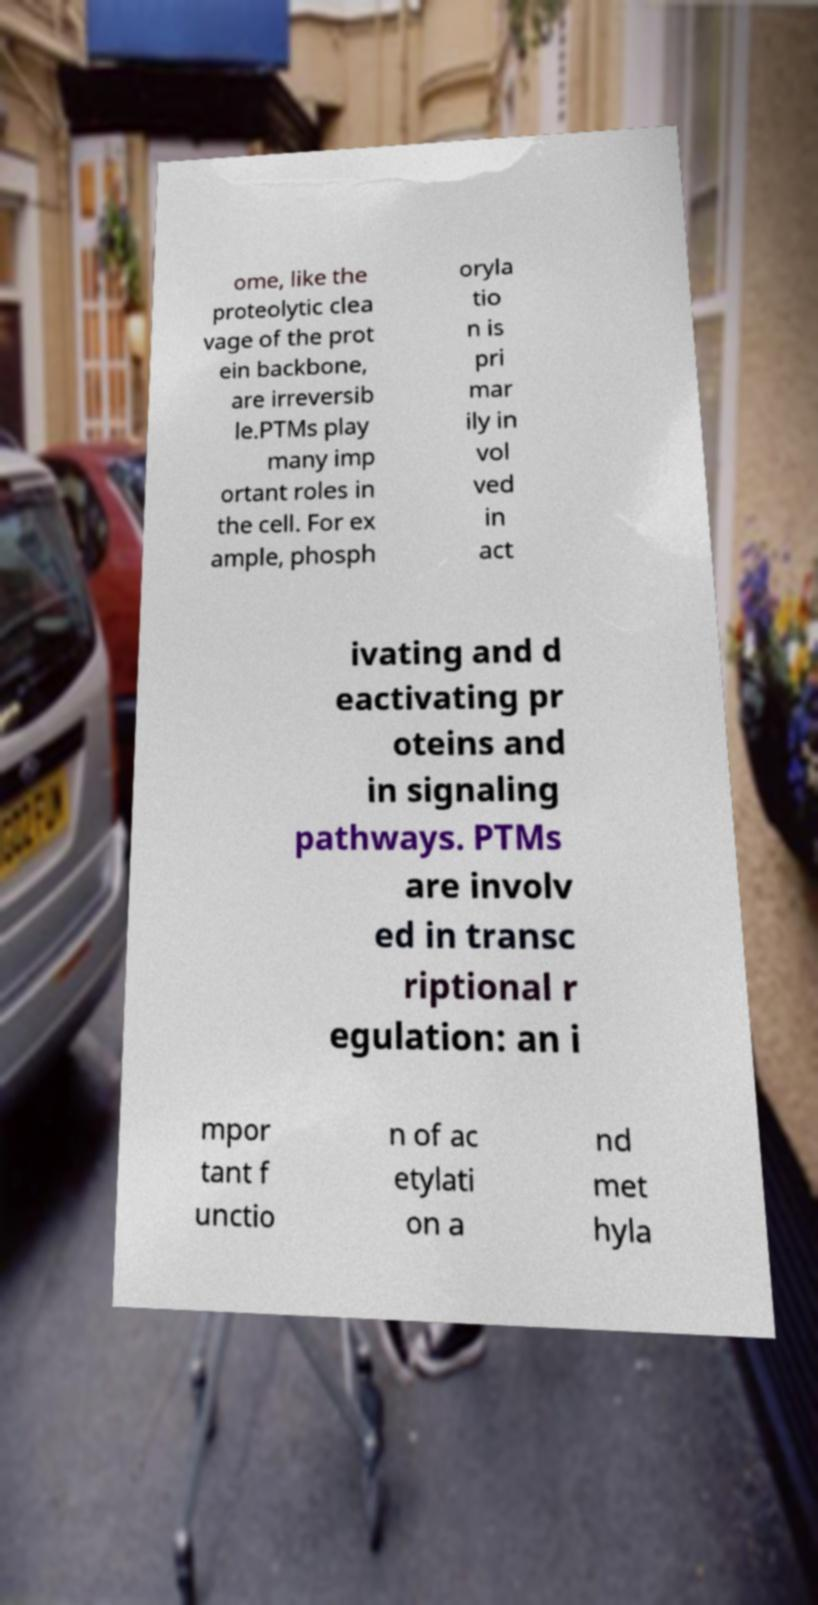What messages or text are displayed in this image? I need them in a readable, typed format. ome, like the proteolytic clea vage of the prot ein backbone, are irreversib le.PTMs play many imp ortant roles in the cell. For ex ample, phosph oryla tio n is pri mar ily in vol ved in act ivating and d eactivating pr oteins and in signaling pathways. PTMs are involv ed in transc riptional r egulation: an i mpor tant f unctio n of ac etylati on a nd met hyla 